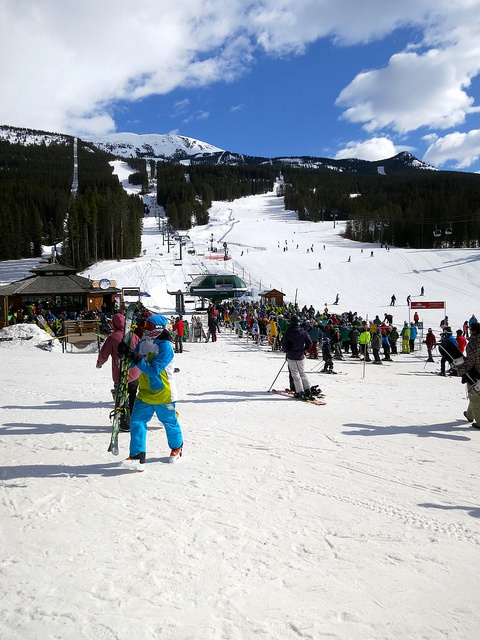Describe the objects in this image and their specific colors. I can see people in lightgray, black, gray, and darkgray tones, people in lightgray, blue, black, and lightblue tones, people in lightgray, black, gray, and darkgray tones, people in lightgray, black, maroon, brown, and white tones, and people in lightgray, black, darkgreen, and gray tones in this image. 